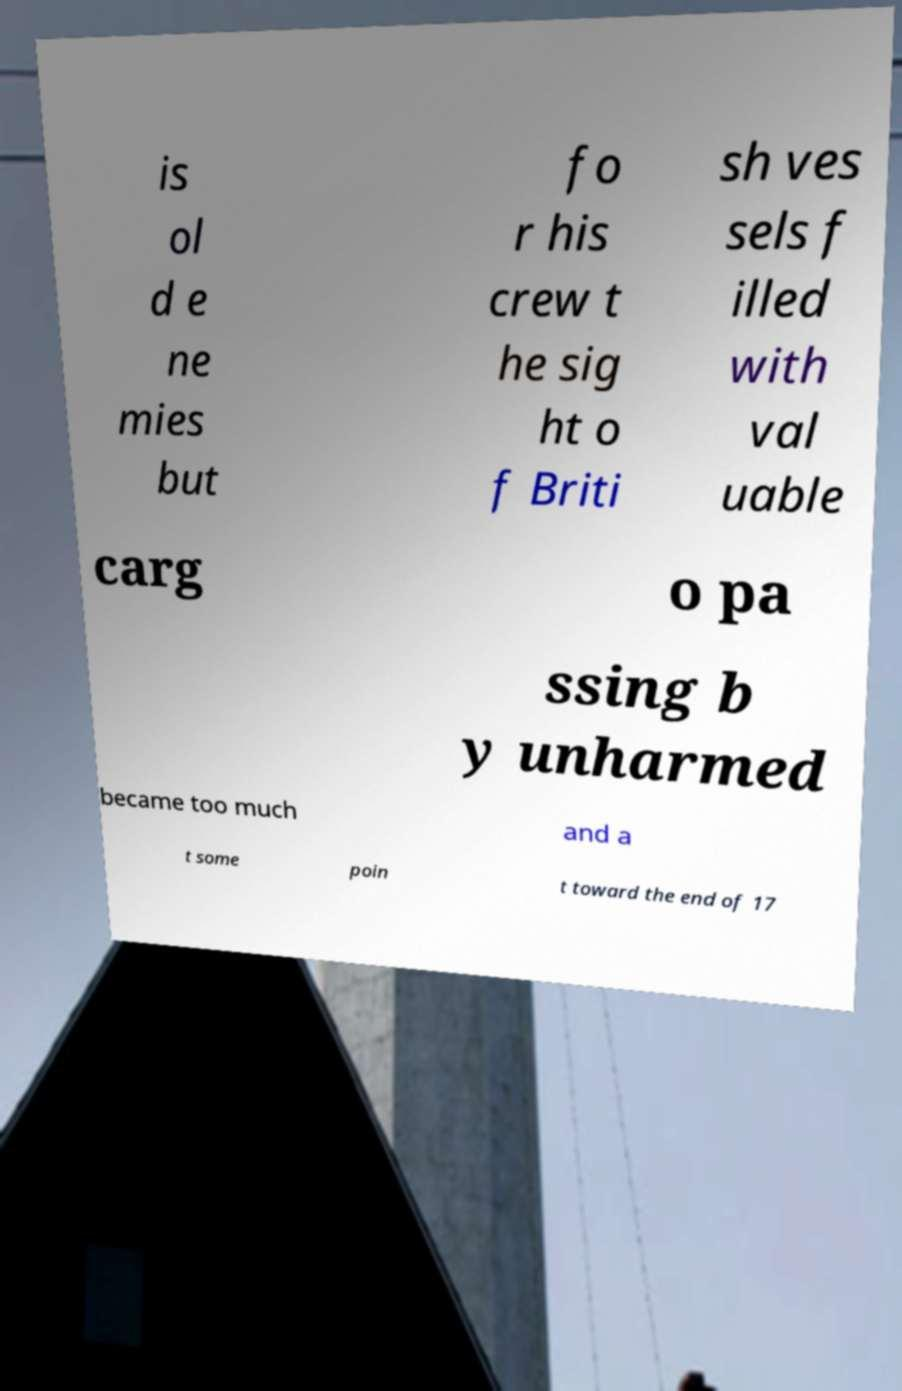Can you read and provide the text displayed in the image?This photo seems to have some interesting text. Can you extract and type it out for me? is ol d e ne mies but fo r his crew t he sig ht o f Briti sh ves sels f illed with val uable carg o pa ssing b y unharmed became too much and a t some poin t toward the end of 17 